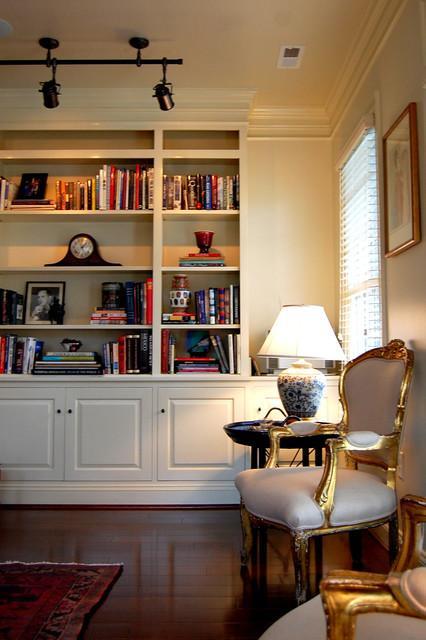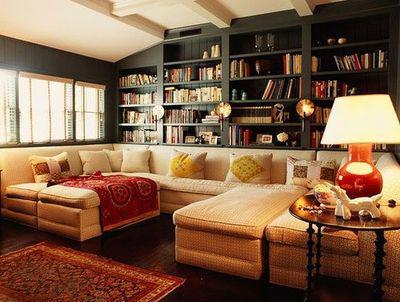The first image is the image on the left, the second image is the image on the right. For the images shown, is this caption "In one room, the back of a sofa is against the wall containing bookshelves and behind an oriental-type rug." true? Answer yes or no. Yes. 